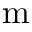Convert formula to latex. <formula><loc_0><loc_0><loc_500><loc_500>m</formula> 